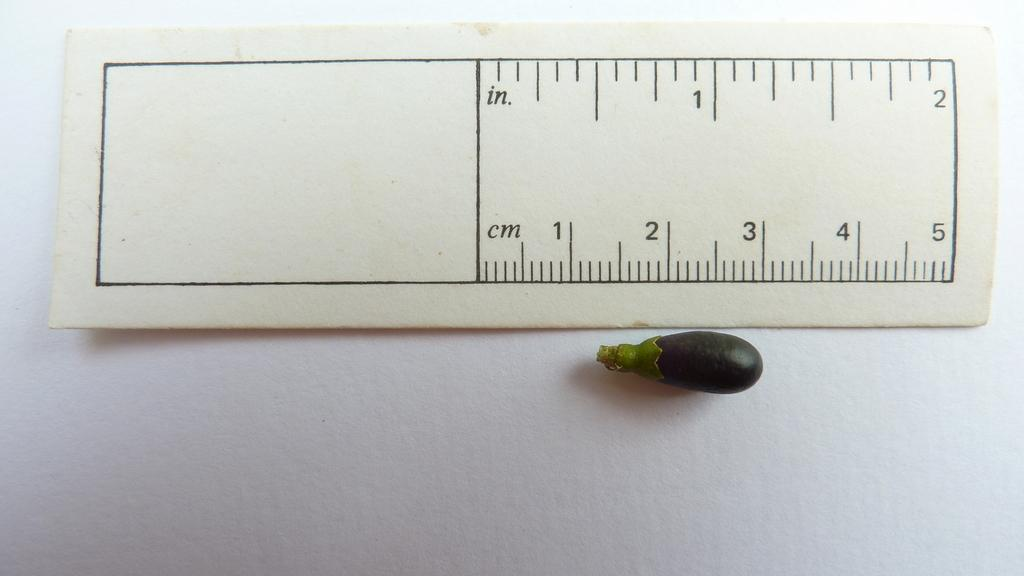<image>
Give a short and clear explanation of the subsequent image. A small paper ruler that measures 2 inches is above a small plant. 